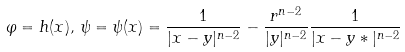Convert formula to latex. <formula><loc_0><loc_0><loc_500><loc_500>\varphi = h ( x ) , \, \psi = \psi ( x ) = \frac { 1 } { | x - y | ^ { n - 2 } } - \frac { r ^ { n - 2 } } { | y | ^ { n - 2 } } \frac { 1 } { | x - y * | ^ { n - 2 } }</formula> 